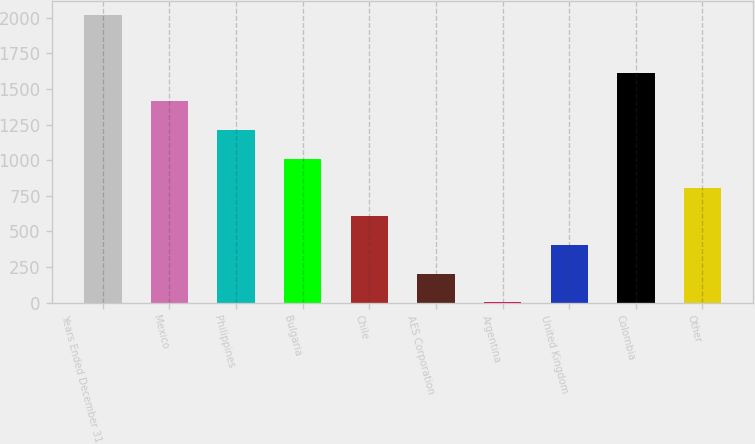Convert chart. <chart><loc_0><loc_0><loc_500><loc_500><bar_chart><fcel>Years Ended December 31<fcel>Mexico<fcel>Philippines<fcel>Bulgaria<fcel>Chile<fcel>AES Corporation<fcel>Argentina<fcel>United Kingdom<fcel>Colombia<fcel>Other<nl><fcel>2017<fcel>1412.2<fcel>1210.6<fcel>1009<fcel>605.8<fcel>202.6<fcel>1<fcel>404.2<fcel>1613.8<fcel>807.4<nl></chart> 